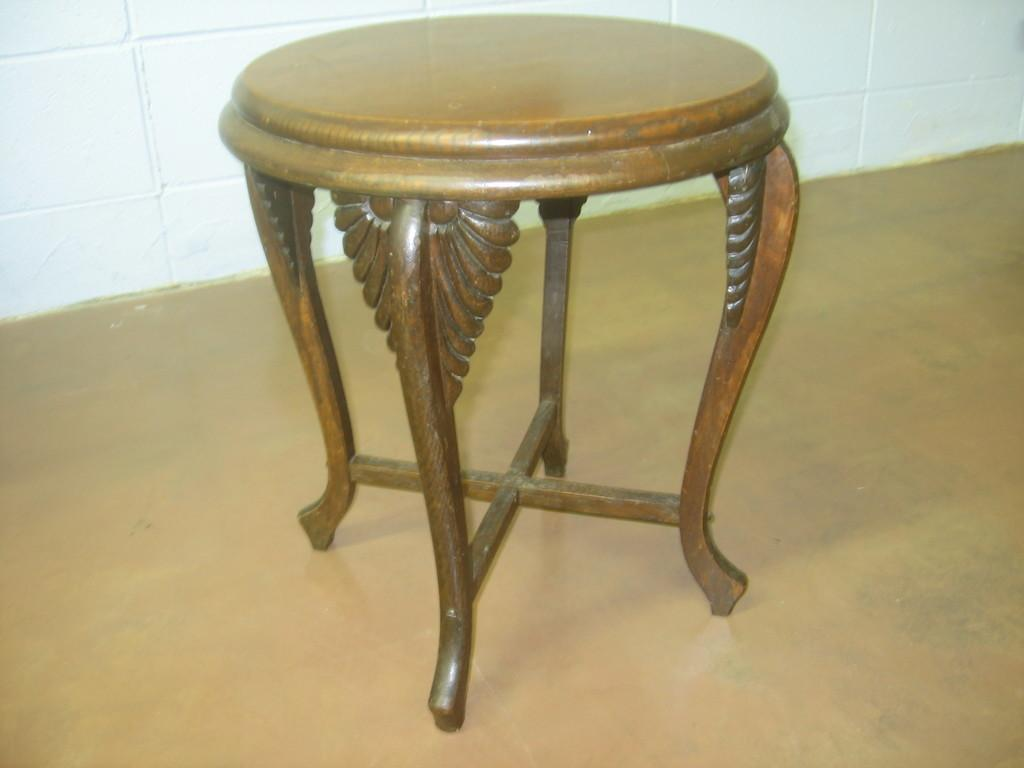What piece of furniture is on the floor in the image? There is a stool on the floor in the image. What type of structure can be seen in the background? There is a wall in the image. What type of sugar is being used to sweeten the nation's health in the image? There is no reference to sugar, nation, or health in the image, so it is not possible to answer that question. 